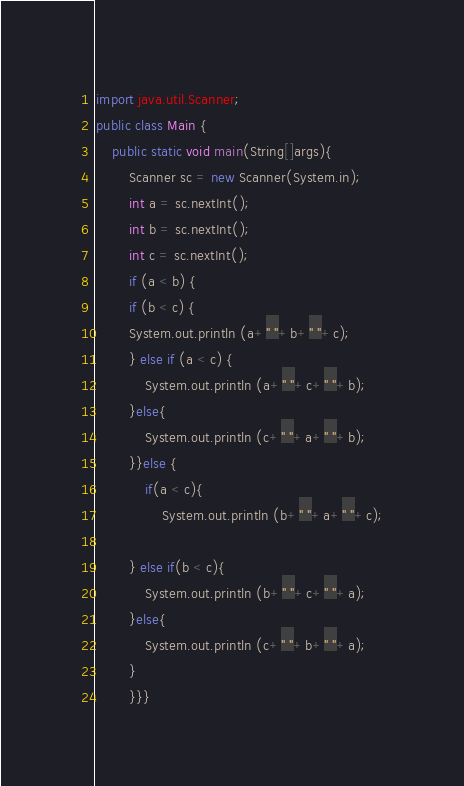Convert code to text. <code><loc_0><loc_0><loc_500><loc_500><_Java_>import java.util.Scanner;
public class Main {
	public static void main(String[]args){
		Scanner sc = new Scanner(System.in);
	    int a = sc.nextInt();
		int b = sc.nextInt();
		int c = sc.nextInt();
		if (a < b) {
		if (b < c) {
		System.out.println (a+" "+b+" "+c);
		} else if (a < c) {
			System.out.println (a+" "+c+" "+b);
		}else{
			System.out.println (c+" "+a+" "+b);
		}}else {
			if(a < c){
				System.out.println (b+" "+a+" "+c);
		
		} else if(b < c){
			System.out.println (b+" "+c+" "+a);
		}else{
			System.out.println (c+" "+b+" "+a);
		}
		}}}</code> 